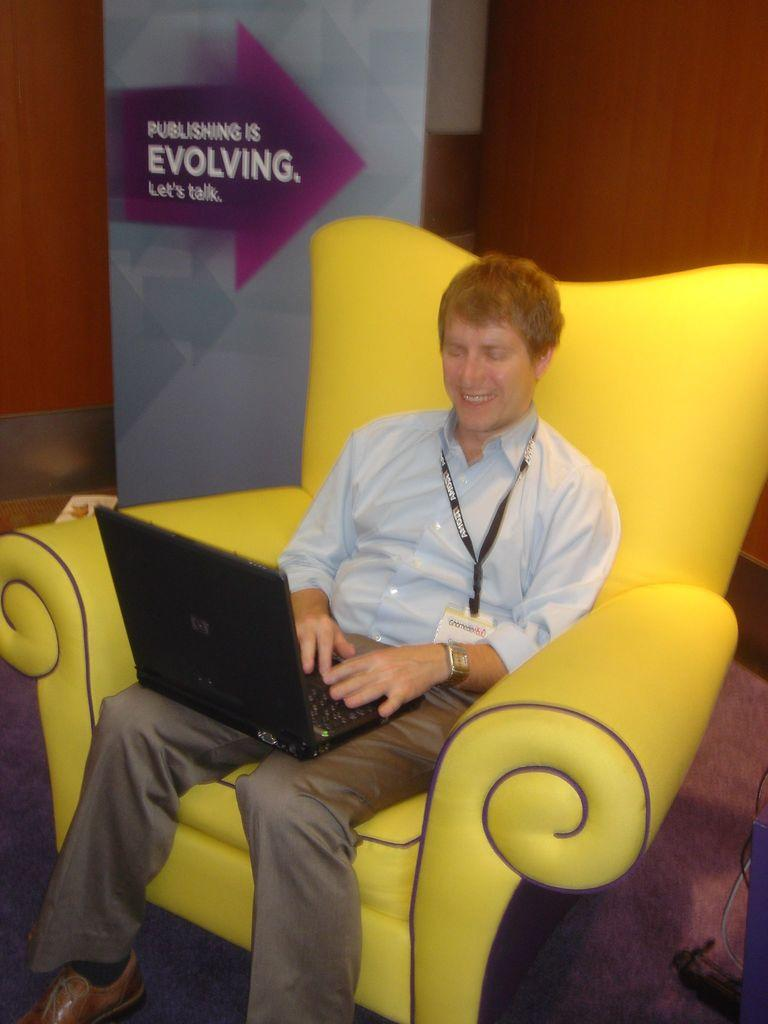What is the person in the image doing? The person is sitting on a chair in the image. What is the person's facial expression? The person is smiling in the image. What object is the person holding? The person is holding a laptop in the image. Is there any identification on the person? Yes, the person is wearing a tag in the image. What can be seen in the background of the image? There is a banner and a wall in the background of the image. What type of worm can be seen crawling on the person's laptop in the image? There is no worm present in the image; the person is holding a laptop without any visible worms. 